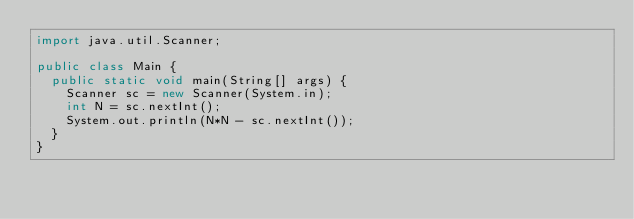<code> <loc_0><loc_0><loc_500><loc_500><_Java_>import java.util.Scanner;

public class Main {
	public static void main(String[] args) {
		Scanner sc = new Scanner(System.in);
		int N = sc.nextInt();
		System.out.println(N*N - sc.nextInt());
	}
}
</code> 